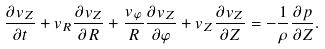Convert formula to latex. <formula><loc_0><loc_0><loc_500><loc_500>\frac { \partial v _ { Z } } { \partial t } + v _ { R } \frac { \partial v _ { Z } } { \partial R } + \frac { v _ { \varphi } } { R } \frac { \partial v _ { Z } } { \partial \varphi } + v _ { Z } \frac { \partial v _ { Z } } { \partial Z } = - \frac { 1 } { \rho } \frac { \partial p } { \partial Z } .</formula> 